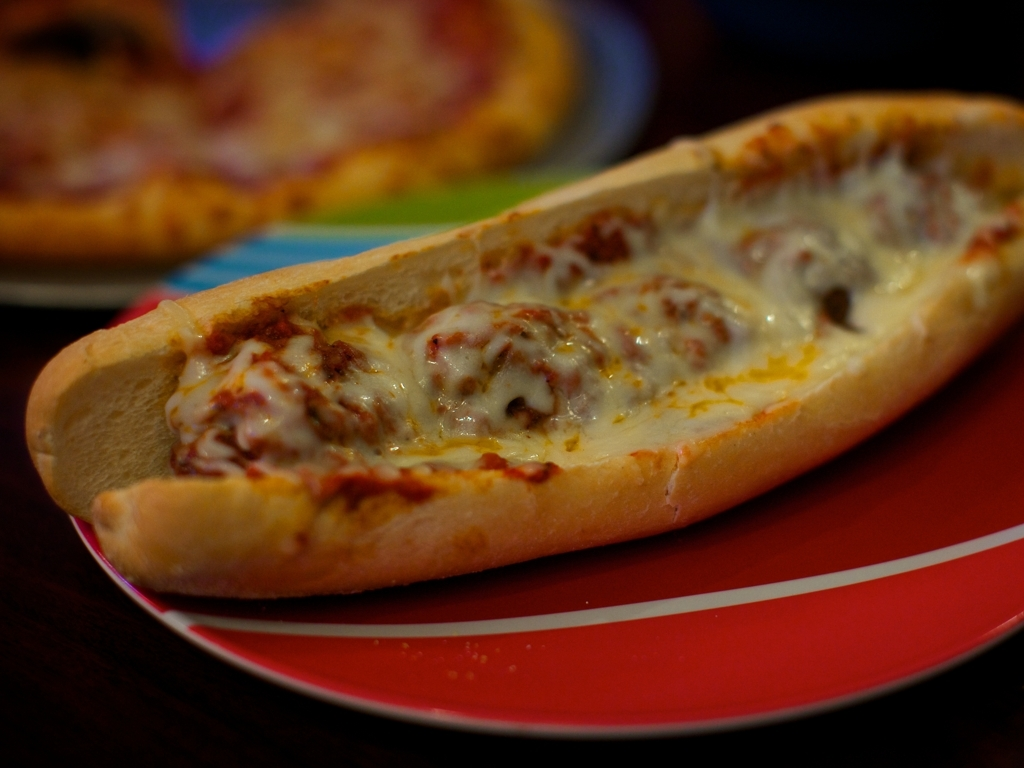Where is this food typically consumed? This type of food is commonly enjoyed in casual dining establishments, at home as a quick meal, or as a take-out or delivery option for those seeking convenience. 